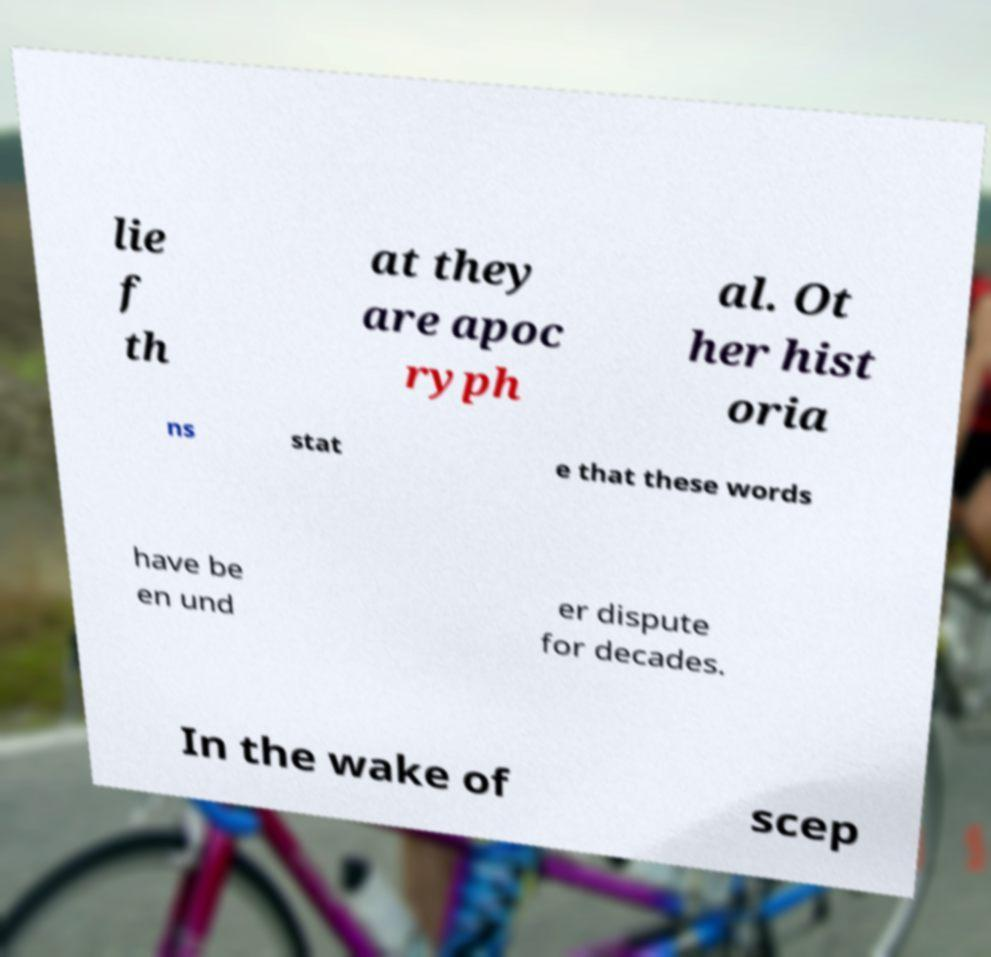Can you read and provide the text displayed in the image?This photo seems to have some interesting text. Can you extract and type it out for me? lie f th at they are apoc ryph al. Ot her hist oria ns stat e that these words have be en und er dispute for decades. In the wake of scep 